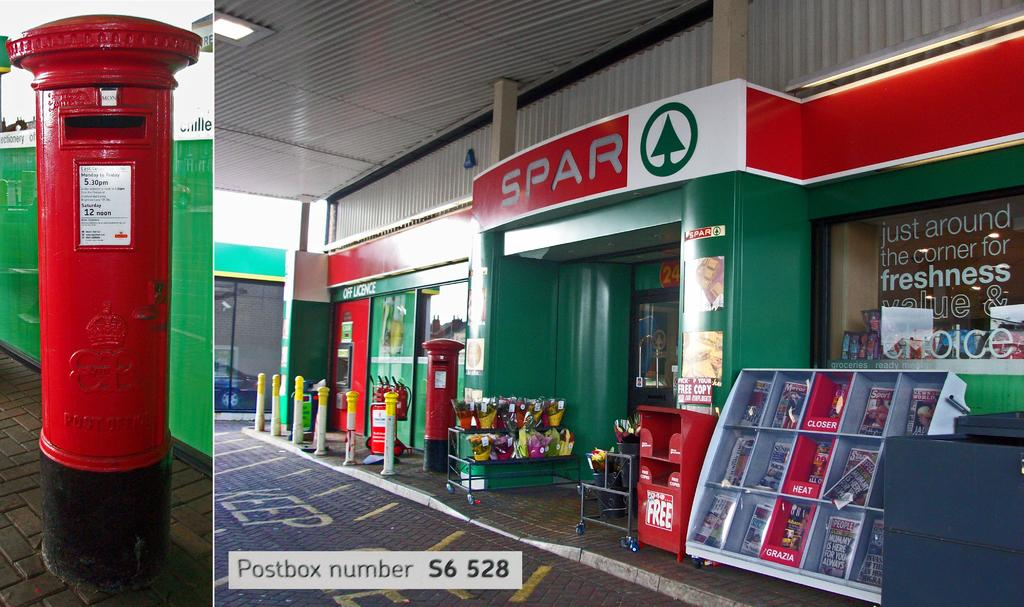<image>
Summarize the visual content of the image. Spar is written on a red and white sign above the green entrance to the store. 